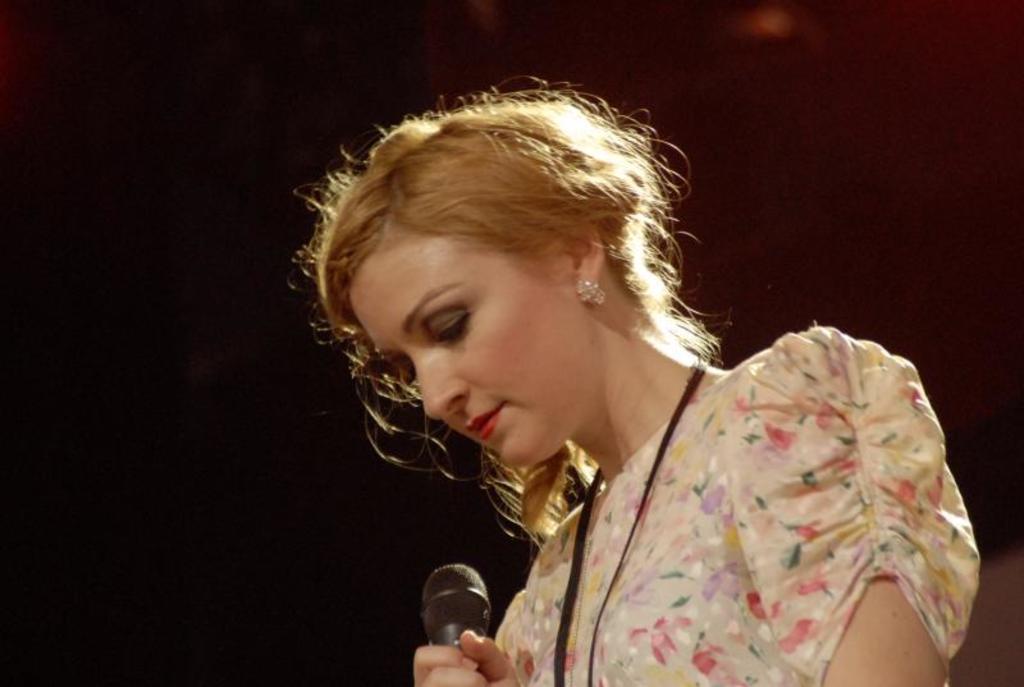Describe this image in one or two sentences. This image consists of a woman. She is in the middle of the image. She is holding Mike in her hand. She has earrings to her ears. She wore ID card, she wore cream color dress. 